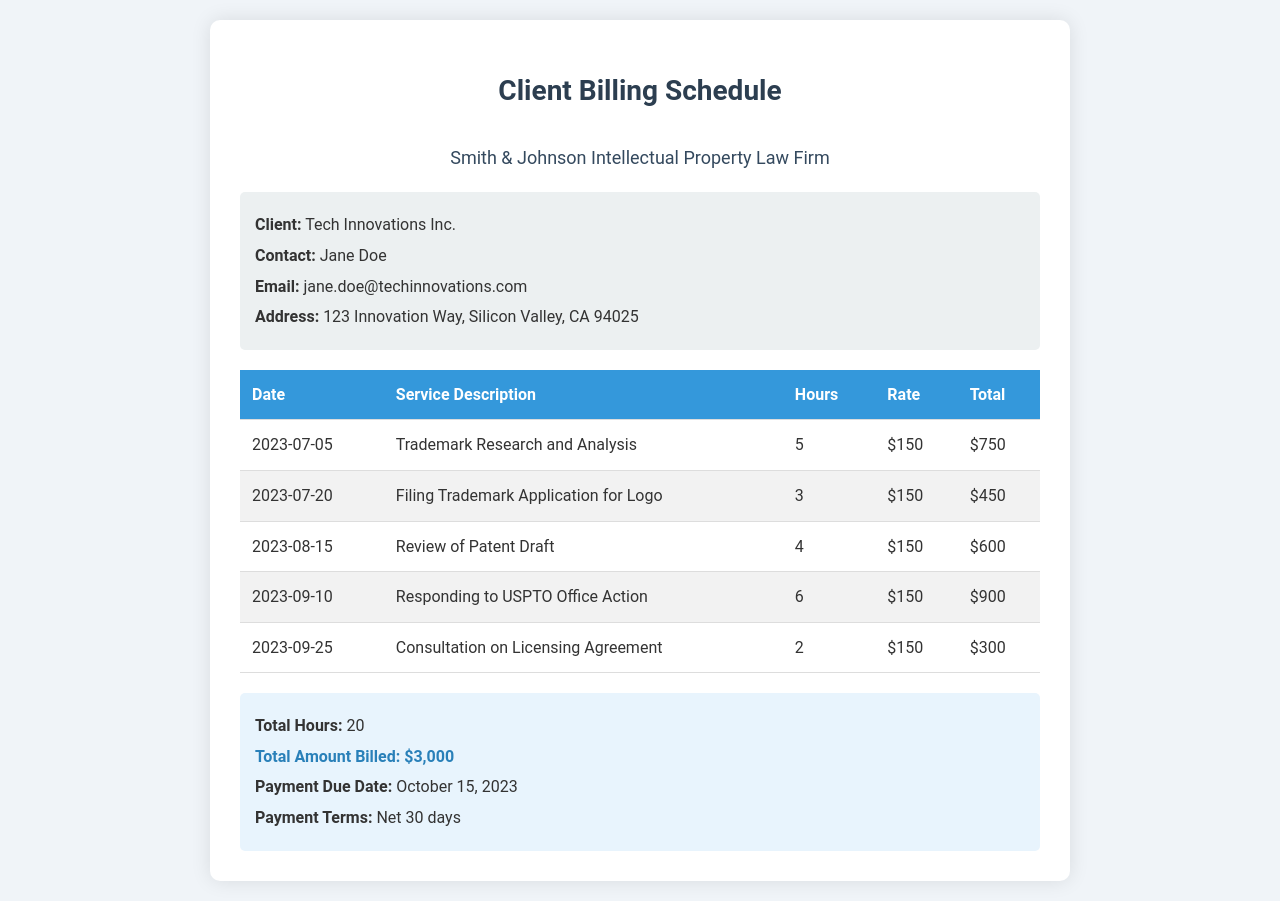What is the client's name? The client's name is explicitly stated in the document under "Client."
Answer: Tech Innovations Inc Who is the main contact person for the client? The document provides a contact person in the client details section.
Answer: Jane Doe What is the total amount billed? The total amount billed is summarized in the document's summary section.
Answer: $3,000 On what date is the payment due? The due date for payment is clearly indicated in the summary part of the document.
Answer: October 15, 2023 How many hours were worked in total? The total hours worked are listed in the summary section of the document.
Answer: 20 What was the service description for the date 2023-09-10? The document lists specific service descriptions along with their corresponding dates.
Answer: Responding to USPTO Office Action What is the hourly rate charged for services? The hourly rate is consistently mentioned across the different service entries in the document.
Answer: $150 How many services were rendered in July 2023? The table includes individual entries for services by date; specifically, July 2023 had two entries.
Answer: 2 What is the name of the law firm? The law firm's name is prominently displayed at the top of the document.
Answer: Smith & Johnson Intellectual Property Law Firm 